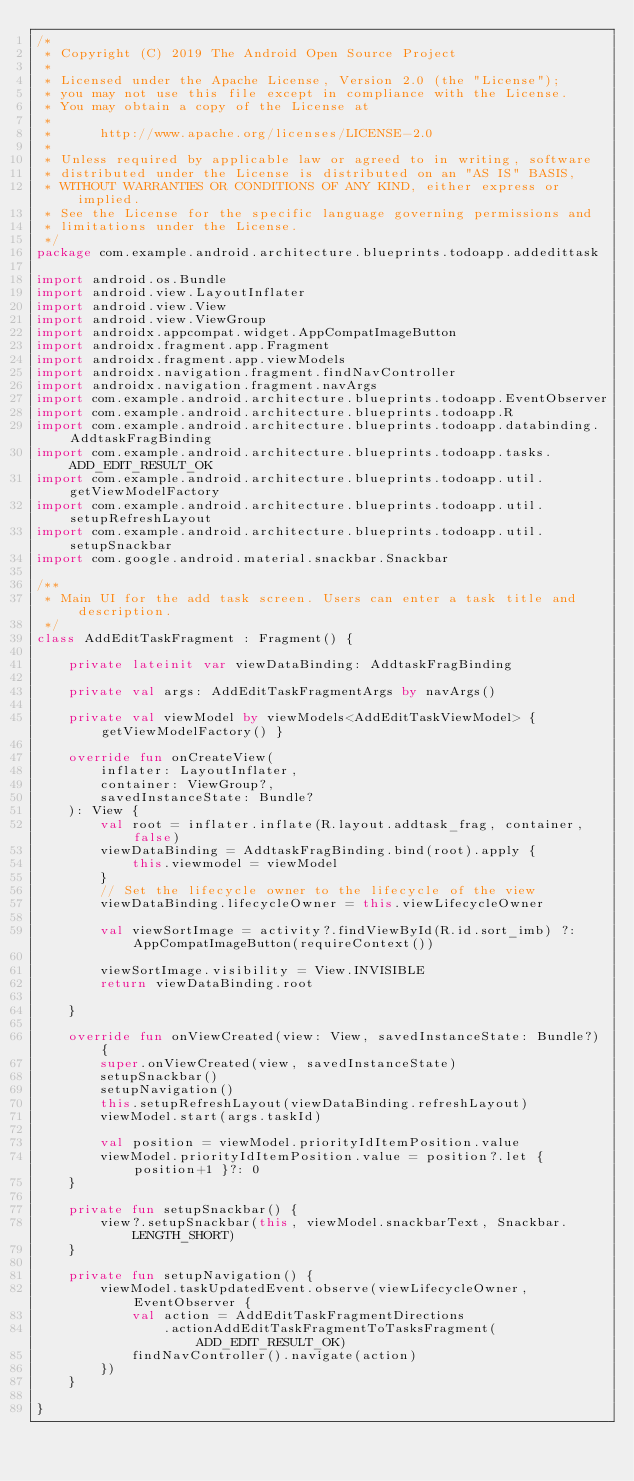Convert code to text. <code><loc_0><loc_0><loc_500><loc_500><_Kotlin_>/*
 * Copyright (C) 2019 The Android Open Source Project
 *
 * Licensed under the Apache License, Version 2.0 (the "License");
 * you may not use this file except in compliance with the License.
 * You may obtain a copy of the License at
 *
 *      http://www.apache.org/licenses/LICENSE-2.0
 *
 * Unless required by applicable law or agreed to in writing, software
 * distributed under the License is distributed on an "AS IS" BASIS,
 * WITHOUT WARRANTIES OR CONDITIONS OF ANY KIND, either express or implied.
 * See the License for the specific language governing permissions and
 * limitations under the License.
 */
package com.example.android.architecture.blueprints.todoapp.addedittask

import android.os.Bundle
import android.view.LayoutInflater
import android.view.View
import android.view.ViewGroup
import androidx.appcompat.widget.AppCompatImageButton
import androidx.fragment.app.Fragment
import androidx.fragment.app.viewModels
import androidx.navigation.fragment.findNavController
import androidx.navigation.fragment.navArgs
import com.example.android.architecture.blueprints.todoapp.EventObserver
import com.example.android.architecture.blueprints.todoapp.R
import com.example.android.architecture.blueprints.todoapp.databinding.AddtaskFragBinding
import com.example.android.architecture.blueprints.todoapp.tasks.ADD_EDIT_RESULT_OK
import com.example.android.architecture.blueprints.todoapp.util.getViewModelFactory
import com.example.android.architecture.blueprints.todoapp.util.setupRefreshLayout
import com.example.android.architecture.blueprints.todoapp.util.setupSnackbar
import com.google.android.material.snackbar.Snackbar

/**
 * Main UI for the add task screen. Users can enter a task title and description.
 */
class AddEditTaskFragment : Fragment() {

    private lateinit var viewDataBinding: AddtaskFragBinding

    private val args: AddEditTaskFragmentArgs by navArgs()

    private val viewModel by viewModels<AddEditTaskViewModel> { getViewModelFactory() }

    override fun onCreateView(
        inflater: LayoutInflater,
        container: ViewGroup?,
        savedInstanceState: Bundle?
    ): View {
        val root = inflater.inflate(R.layout.addtask_frag, container, false)
        viewDataBinding = AddtaskFragBinding.bind(root).apply {
            this.viewmodel = viewModel
        }
        // Set the lifecycle owner to the lifecycle of the view
        viewDataBinding.lifecycleOwner = this.viewLifecycleOwner

        val viewSortImage = activity?.findViewById(R.id.sort_imb) ?: AppCompatImageButton(requireContext())

        viewSortImage.visibility = View.INVISIBLE
        return viewDataBinding.root

    }

    override fun onViewCreated(view: View, savedInstanceState: Bundle?) {
        super.onViewCreated(view, savedInstanceState)
        setupSnackbar()
        setupNavigation()
        this.setupRefreshLayout(viewDataBinding.refreshLayout)
        viewModel.start(args.taskId)

        val position = viewModel.priorityIdItemPosition.value
        viewModel.priorityIdItemPosition.value = position?.let { position+1 }?: 0
    }

    private fun setupSnackbar() {
        view?.setupSnackbar(this, viewModel.snackbarText, Snackbar.LENGTH_SHORT)
    }

    private fun setupNavigation() {
        viewModel.taskUpdatedEvent.observe(viewLifecycleOwner, EventObserver {
            val action = AddEditTaskFragmentDirections
                .actionAddEditTaskFragmentToTasksFragment(ADD_EDIT_RESULT_OK)
            findNavController().navigate(action)
        })
    }

}
</code> 